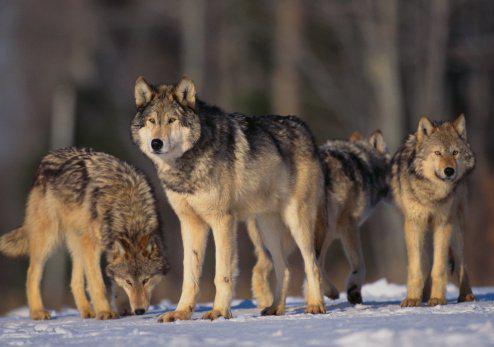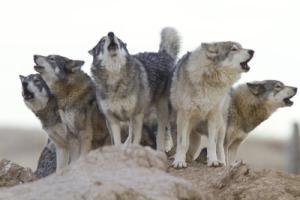The first image is the image on the left, the second image is the image on the right. Assess this claim about the two images: "In the right image, there are four wolves in the snow.". Correct or not? Answer yes or no. No. 